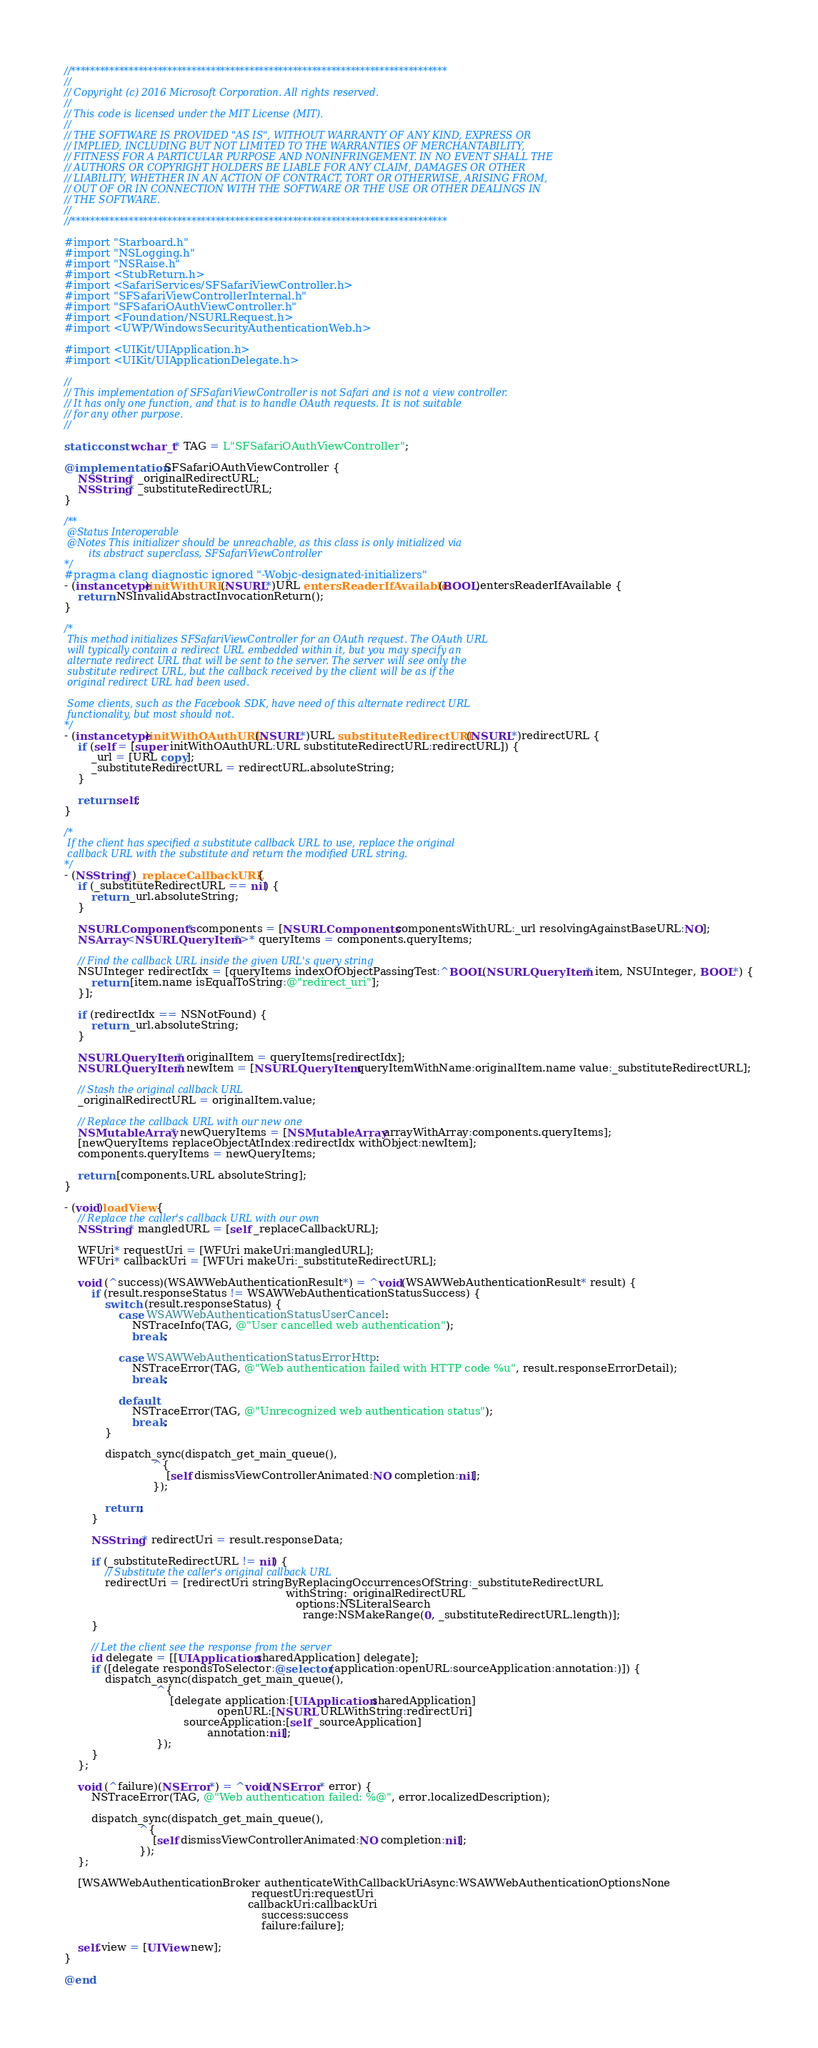Convert code to text. <code><loc_0><loc_0><loc_500><loc_500><_ObjectiveC_>//******************************************************************************
//
// Copyright (c) 2016 Microsoft Corporation. All rights reserved.
//
// This code is licensed under the MIT License (MIT).
//
// THE SOFTWARE IS PROVIDED "AS IS", WITHOUT WARRANTY OF ANY KIND, EXPRESS OR
// IMPLIED, INCLUDING BUT NOT LIMITED TO THE WARRANTIES OF MERCHANTABILITY,
// FITNESS FOR A PARTICULAR PURPOSE AND NONINFRINGEMENT. IN NO EVENT SHALL THE
// AUTHORS OR COPYRIGHT HOLDERS BE LIABLE FOR ANY CLAIM, DAMAGES OR OTHER
// LIABILITY, WHETHER IN AN ACTION OF CONTRACT, TORT OR OTHERWISE, ARISING FROM,
// OUT OF OR IN CONNECTION WITH THE SOFTWARE OR THE USE OR OTHER DEALINGS IN
// THE SOFTWARE.
//
//******************************************************************************

#import "Starboard.h"
#import "NSLogging.h"
#import "NSRaise.h"
#import <StubReturn.h>
#import <SafariServices/SFSafariViewController.h>
#import "SFSafariViewControllerInternal.h"
#import "SFSafariOAuthViewController.h"
#import <Foundation/NSURLRequest.h>
#import <UWP/WindowsSecurityAuthenticationWeb.h>

#import <UIKit/UIApplication.h>
#import <UIKit/UIApplicationDelegate.h>

//
// This implementation of SFSafariViewController is not Safari and is not a view controller.
// It has only one function, and that is to handle OAuth requests. It is not suitable
// for any other purpose.
//

static const wchar_t* TAG = L"SFSafariOAuthViewController";

@implementation SFSafariOAuthViewController {
    NSString* _originalRedirectURL;
    NSString* _substituteRedirectURL;
}

/**
 @Status Interoperable
 @Notes This initializer should be unreachable, as this class is only initialized via
        its abstract superclass, SFSafariViewController
*/
#pragma clang diagnostic ignored "-Wobjc-designated-initializers"
- (instancetype)initWithURL:(NSURL*)URL entersReaderIfAvailable:(BOOL)entersReaderIfAvailable {
    return NSInvalidAbstractInvocationReturn();
}

/*
 This method initializes SFSafariViewController for an OAuth request. The OAuth URL
 will typically contain a redirect URL embedded within it, but you may specify an
 alternate redirect URL that will be sent to the server. The server will see only the
 substitute redirect URL, but the callback received by the client will be as if the
 original redirect URL had been used.

 Some clients, such as the Facebook SDK, have need of this alternate redirect URL
 functionality, but most should not.
*/
- (instancetype)initWithOAuthURL:(NSURL*)URL substituteRedirectURL:(NSURL*)redirectURL {
    if (self = [super initWithOAuthURL:URL substituteRedirectURL:redirectURL]) {
        _url = [URL copy];
        _substituteRedirectURL = redirectURL.absoluteString;
    }

    return self;
}

/*
 If the client has specified a substitute callback URL to use, replace the original
 callback URL with the substitute and return the modified URL string.
*/
- (NSString*)_replaceCallbackURL {
    if (_substituteRedirectURL == nil) {
        return _url.absoluteString;
    }

    NSURLComponents* components = [NSURLComponents componentsWithURL:_url resolvingAgainstBaseURL:NO];
    NSArray<NSURLQueryItem*>* queryItems = components.queryItems;

    // Find the callback URL inside the given URL's query string
    NSUInteger redirectIdx = [queryItems indexOfObjectPassingTest:^BOOL(NSURLQueryItem* item, NSUInteger, BOOL*) {
        return [item.name isEqualToString:@"redirect_uri"];
    }];

    if (redirectIdx == NSNotFound) {
        return _url.absoluteString;
    }

    NSURLQueryItem* originalItem = queryItems[redirectIdx];
    NSURLQueryItem* newItem = [NSURLQueryItem queryItemWithName:originalItem.name value:_substituteRedirectURL];

    // Stash the original callback URL
    _originalRedirectURL = originalItem.value;

    // Replace the callback URL with our new one
    NSMutableArray* newQueryItems = [NSMutableArray arrayWithArray:components.queryItems];
    [newQueryItems replaceObjectAtIndex:redirectIdx withObject:newItem];
    components.queryItems = newQueryItems;

    return [components.URL absoluteString];
}

- (void)loadView {
    // Replace the caller's callback URL with our own
    NSString* mangledURL = [self _replaceCallbackURL];

    WFUri* requestUri = [WFUri makeUri:mangledURL];
    WFUri* callbackUri = [WFUri makeUri:_substituteRedirectURL];

    void (^success)(WSAWWebAuthenticationResult*) = ^void(WSAWWebAuthenticationResult* result) {
        if (result.responseStatus != WSAWWebAuthenticationStatusSuccess) {
            switch (result.responseStatus) {
                case WSAWWebAuthenticationStatusUserCancel:
                    NSTraceInfo(TAG, @"User cancelled web authentication");
                    break;

                case WSAWWebAuthenticationStatusErrorHttp:
                    NSTraceError(TAG, @"Web authentication failed with HTTP code %u", result.responseErrorDetail);
                    break;

                default:
                    NSTraceError(TAG, @"Unrecognized web authentication status");
                    break;
            }

            dispatch_sync(dispatch_get_main_queue(),
                          ^{
                              [self dismissViewControllerAnimated:NO completion:nil];
                          });

            return;
        }

        NSString* redirectUri = result.responseData;

        if (_substituteRedirectURL != nil) {
            // Substitute the caller's original callback URL
            redirectUri = [redirectUri stringByReplacingOccurrencesOfString:_substituteRedirectURL
                                                                 withString:_originalRedirectURL
                                                                    options:NSLiteralSearch
                                                                      range:NSMakeRange(0, _substituteRedirectURL.length)];
        }

        // Let the client see the response from the server
        id delegate = [[UIApplication sharedApplication] delegate];
        if ([delegate respondsToSelector:@selector(application:openURL:sourceApplication:annotation:)]) {
            dispatch_async(dispatch_get_main_queue(),
                           ^{
                               [delegate application:[UIApplication sharedApplication]
                                             openURL:[NSURL URLWithString:redirectUri]
                                   sourceApplication:[self _sourceApplication]
                                          annotation:nil];
                           });
        }
    };

    void (^failure)(NSError*) = ^void(NSError* error) {
        NSTraceError(TAG, @"Web authentication failed: %@", error.localizedDescription);

        dispatch_sync(dispatch_get_main_queue(),
                      ^{
                          [self dismissViewControllerAnimated:NO completion:nil];
                      });
    };

    [WSAWWebAuthenticationBroker authenticateWithCallbackUriAsync:WSAWWebAuthenticationOptionsNone
                                                       requestUri:requestUri
                                                      callbackUri:callbackUri
                                                          success:success
                                                          failure:failure];

    self.view = [UIView new];
}

@end
</code> 